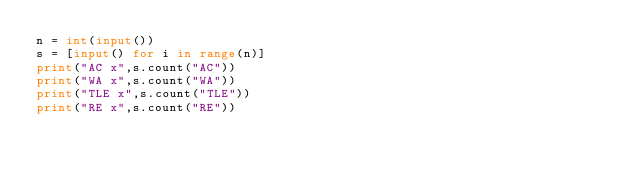<code> <loc_0><loc_0><loc_500><loc_500><_Python_>n = int(input())
s = [input() for i in range(n)]
print("AC x",s.count("AC"))
print("WA x",s.count("WA"))
print("TLE x",s.count("TLE"))
print("RE x",s.count("RE"))</code> 